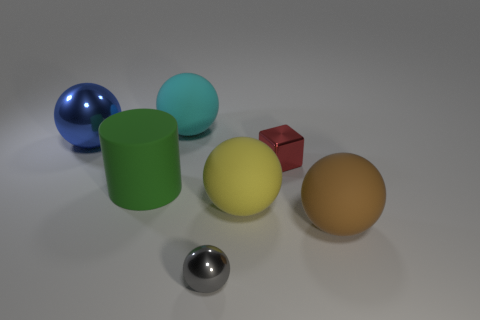Add 1 big cyan matte things. How many objects exist? 8 Subtract all cubes. How many objects are left? 6 Add 4 tiny red objects. How many tiny red objects are left? 5 Add 3 green matte cylinders. How many green matte cylinders exist? 4 Subtract 0 gray cubes. How many objects are left? 7 Subtract all small red shiny blocks. Subtract all gray objects. How many objects are left? 5 